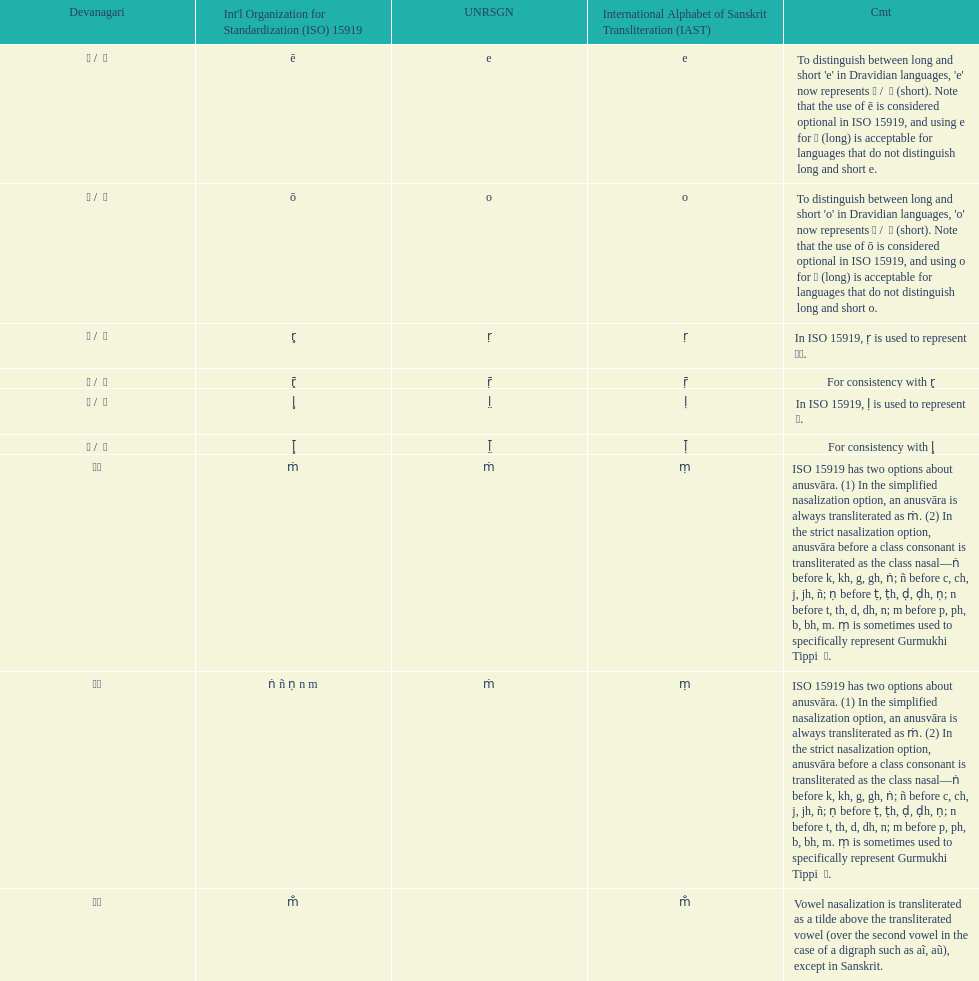What unrsgn is listed previous to the o? E. 